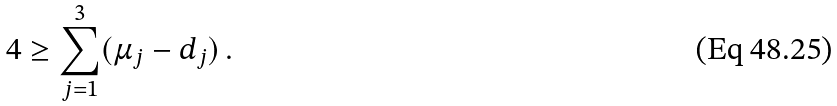<formula> <loc_0><loc_0><loc_500><loc_500>4 \geq \sum _ { j = 1 } ^ { 3 } ( \mu _ { j } - d _ { j } ) \, .</formula> 